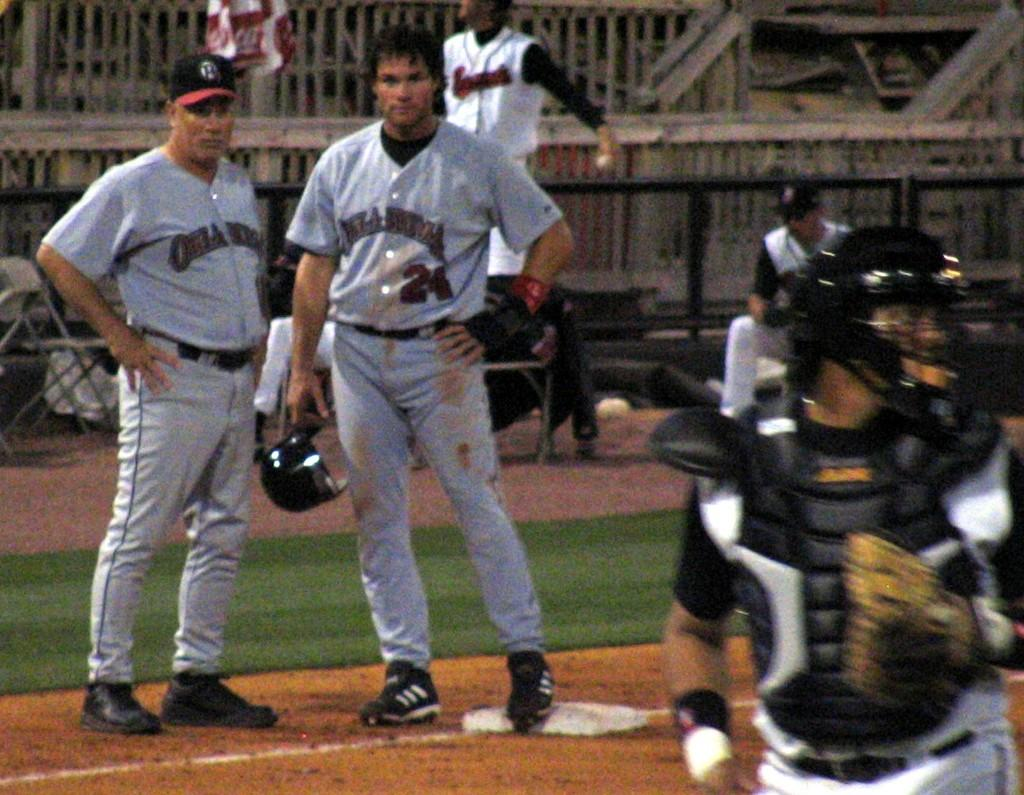<image>
Provide a brief description of the given image. A baseball player wearing a number 24 jersey stands holding his helmet. 